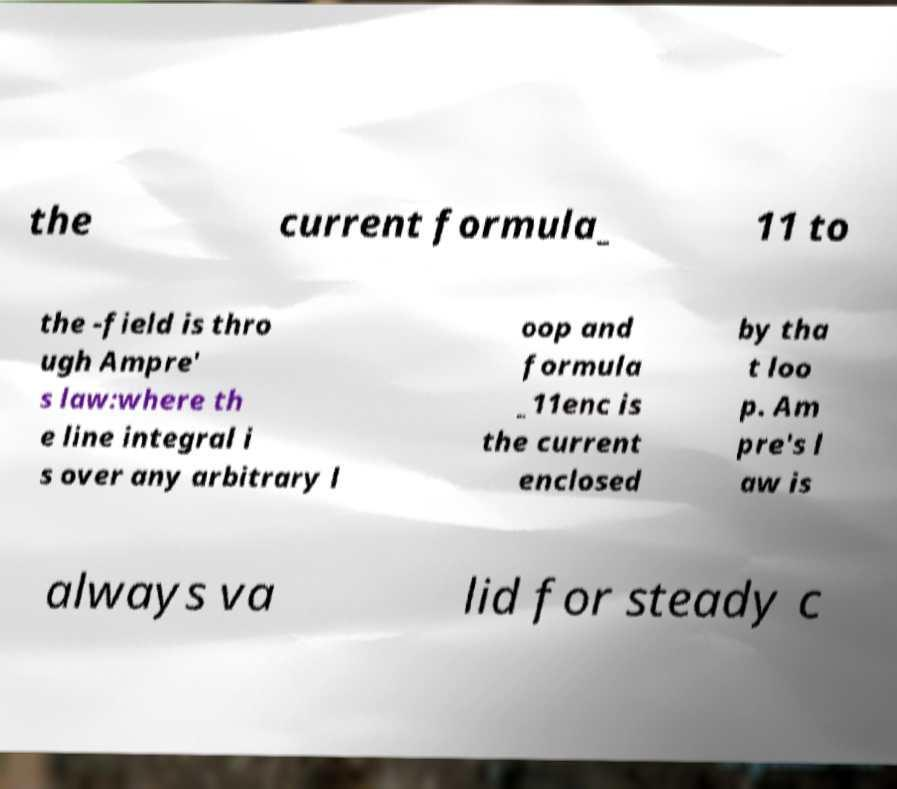Can you accurately transcribe the text from the provided image for me? the current formula_ 11 to the -field is thro ugh Ampre' s law:where th e line integral i s over any arbitrary l oop and formula _11enc is the current enclosed by tha t loo p. Am pre's l aw is always va lid for steady c 